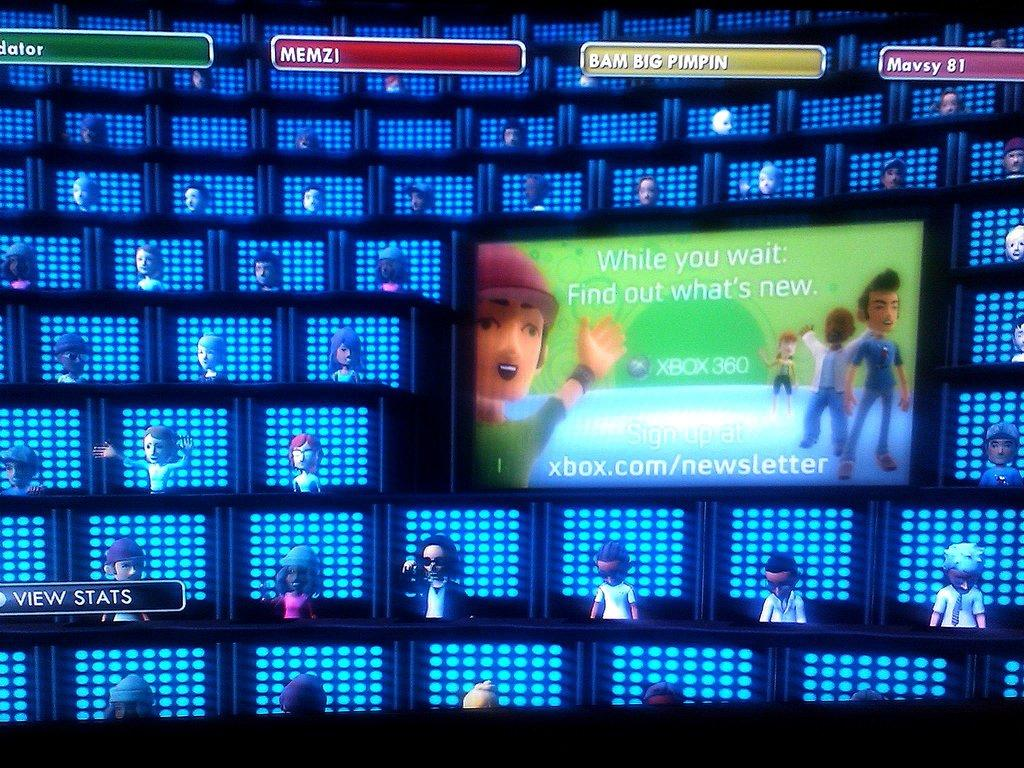<image>
Write a terse but informative summary of the picture. A photo of avatars from the Xbox 360 game. 